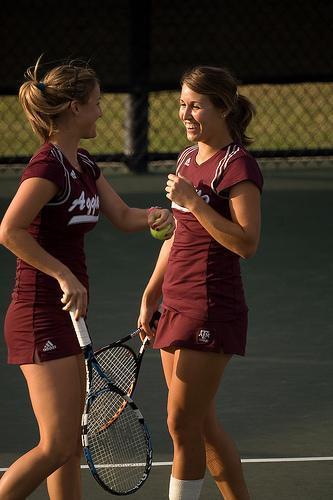How many players are here?
Give a very brief answer. 2. How many girls are holding a ball?
Give a very brief answer. 1. 